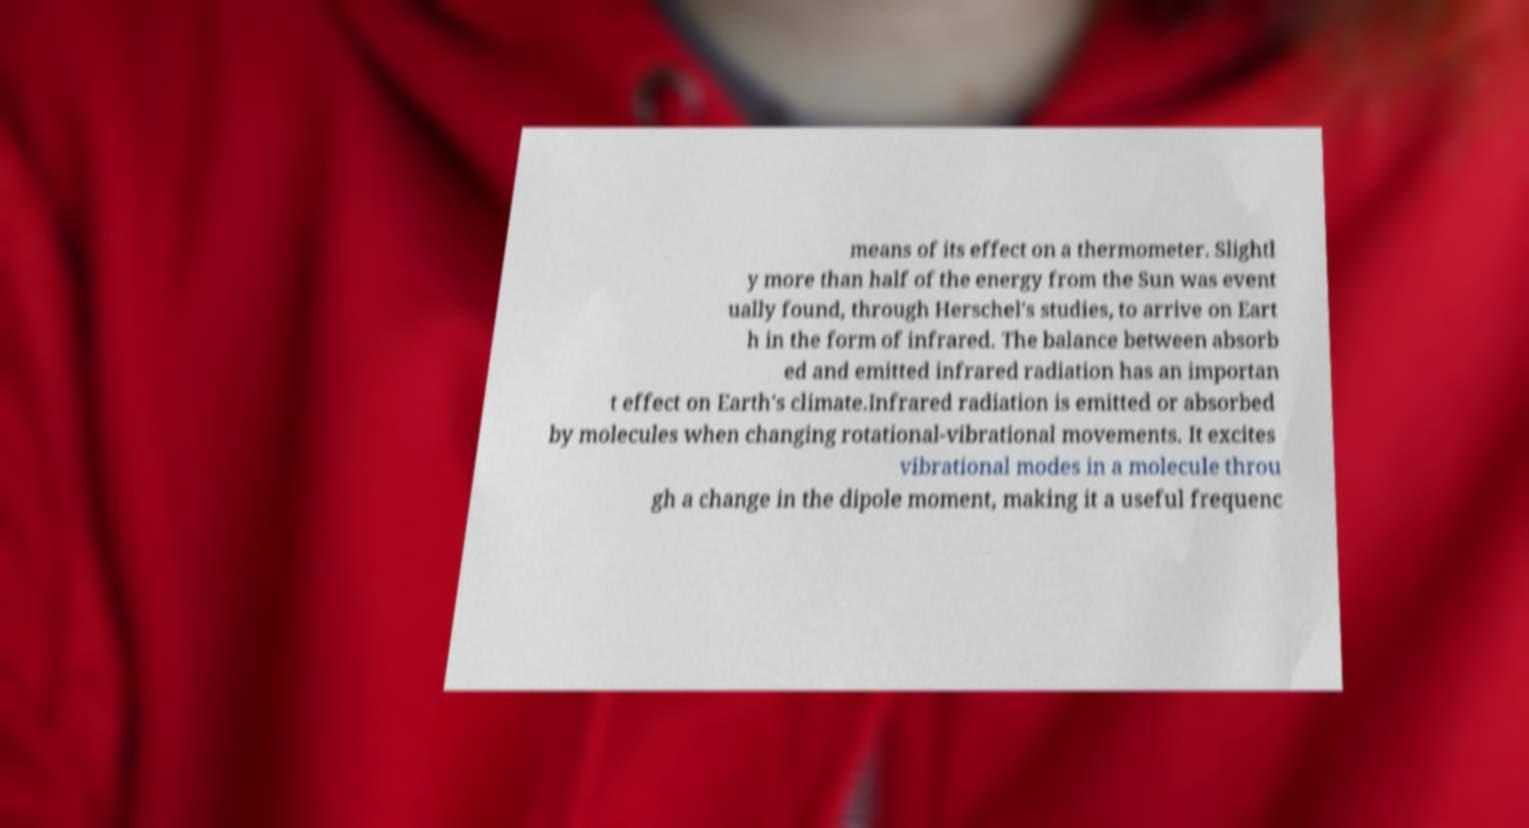I need the written content from this picture converted into text. Can you do that? means of its effect on a thermometer. Slightl y more than half of the energy from the Sun was event ually found, through Herschel's studies, to arrive on Eart h in the form of infrared. The balance between absorb ed and emitted infrared radiation has an importan t effect on Earth's climate.Infrared radiation is emitted or absorbed by molecules when changing rotational-vibrational movements. It excites vibrational modes in a molecule throu gh a change in the dipole moment, making it a useful frequenc 